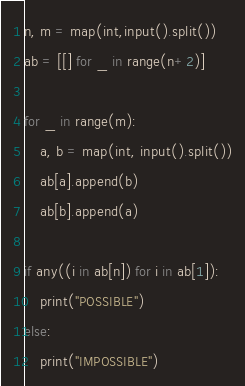Convert code to text. <code><loc_0><loc_0><loc_500><loc_500><_Python_>n, m = map(int,input().split())
ab = [[] for _ in range(n+2)]

for _ in range(m):
    a, b = map(int, input().split())
    ab[a].append(b)
    ab[b].append(a)

if any((i in ab[n]) for i in ab[1]):
    print("POSSIBLE")
else:
    print("IMPOSSIBLE")</code> 